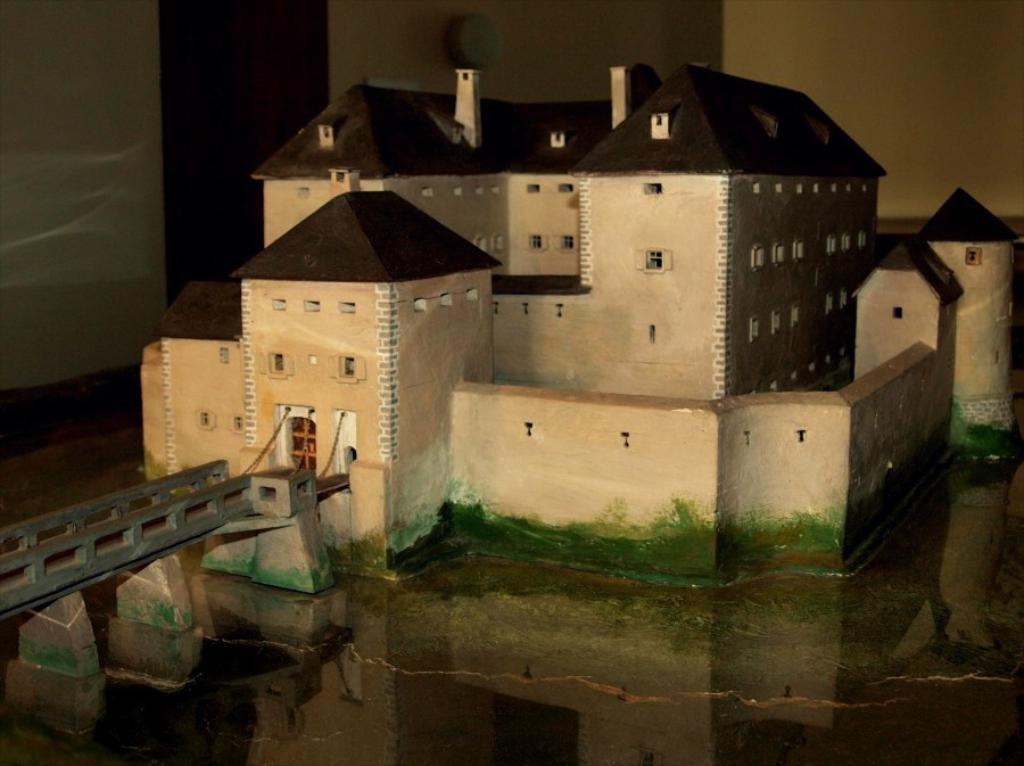In one or two sentences, can you explain what this image depicts? In this picture we can see a miniature of a building with windows, bridge and in the background we can see the walls. 